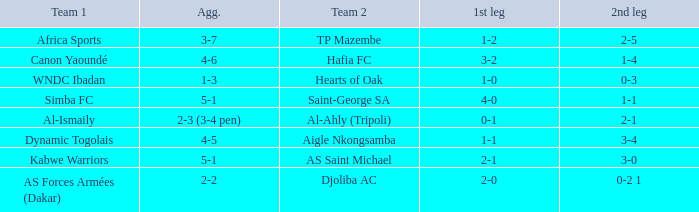Parse the table in full. {'header': ['Team 1', 'Agg.', 'Team 2', '1st leg', '2nd leg'], 'rows': [['Africa Sports', '3-7', 'TP Mazembe', '1-2', '2-5'], ['Canon Yaoundé', '4-6', 'Hafia FC', '3-2', '1-4'], ['WNDC Ibadan', '1-3', 'Hearts of Oak', '1-0', '0-3'], ['Simba FC', '5-1', 'Saint-George SA', '4-0', '1-1'], ['Al-Ismaily', '2-3 (3-4 pen)', 'Al-Ahly (Tripoli)', '0-1', '2-1'], ['Dynamic Togolais', '4-5', 'Aigle Nkongsamba', '1-1', '3-4'], ['Kabwe Warriors', '5-1', 'AS Saint Michael', '2-1', '3-0'], ['AS Forces Armées (Dakar)', '2-2', 'Djoliba AC', '2-0', '0-2 1']]} What was the 2nd leg conclusion in the match that finished 2-0 in the 1st leg? 0-2 1. 